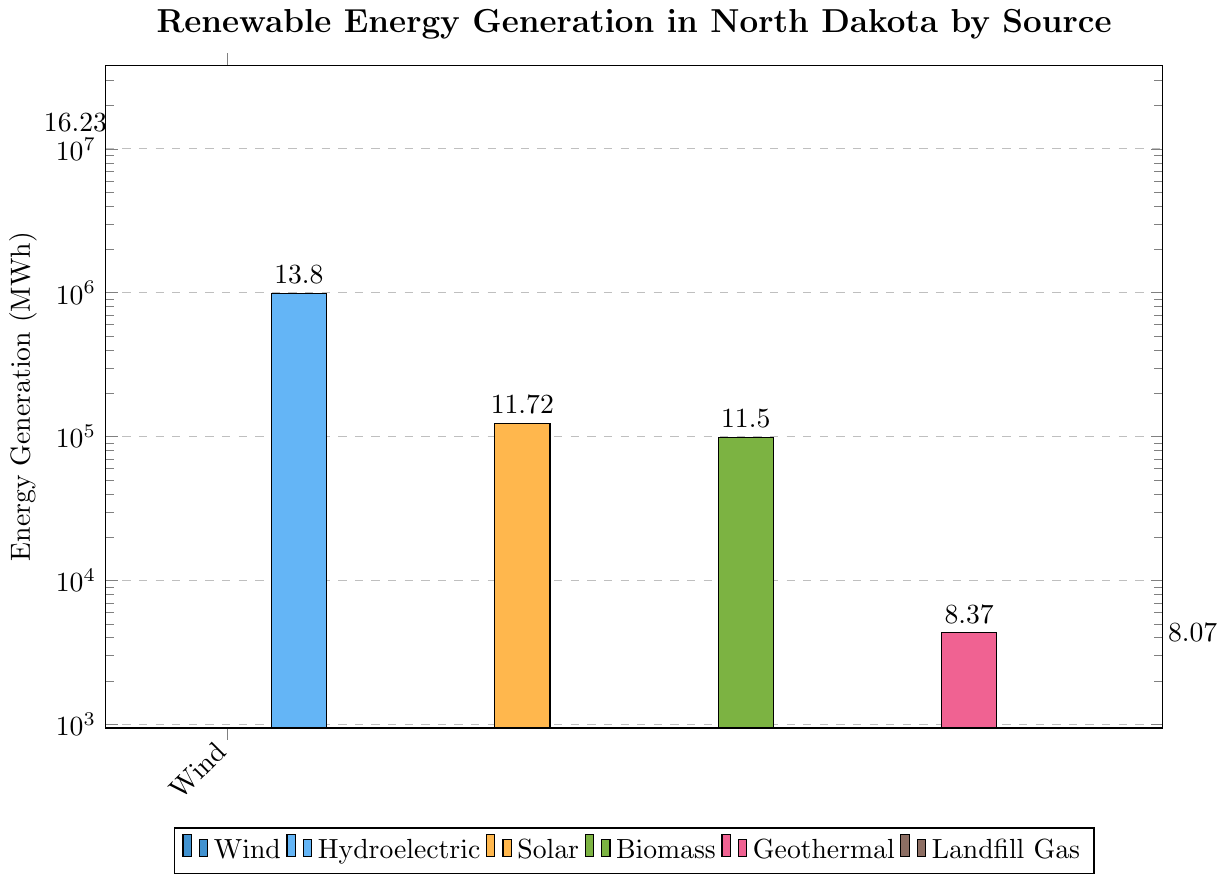Which source generates the most energy in North Dakota? The tallest bar in the chart represents the source that generates the most energy. The Wind energy bar is the tallest.
Answer: Wind Which renewable energy source generates the least amount of energy in North Dakota? The shortest bar in the chart represents the source that generates the least energy. The Landfill Gas energy bar is the shortest.
Answer: Landfill Gas How much more energy is generated by Wind compared to Hydroelectric? Subtract the energy generation of Hydroelectric from Wind. Wind: 11234567 MWh, Hydroelectric: 987654 MWh, the difference is 11234567 - 987654 = 10246913 MWh.
Answer: 10246913 MWh How does Biomass energy generation compare to Geothermal energy generation? Biomass generation value is 98765 MWh, and Geothermal generation value is 4321 MWh. Biomass > Geothermal.
Answer: Biomass generates more energy than Geothermal What's the total energy generation of Solar, Biomass, and Geothermal combined? Sum the energy generation of Solar, Biomass, and Geothermal. Solar: 123456 MWh, Biomass: 98765 MWh, Geothermal: 4321 MWh. The total is 123456 + 98765 + 4321 = 226542 MWh.
Answer: 226542 MWh Which sources have an energy generation amount greater than 1000000 MWh? Identify bars with heights representing values greater than 1000000 MWh. Wind (11234567 MWh) and Hydroelectric (987654 MWh) are considered, but only Wind exceeds 1000000 MWh.
Answer: Wind How many sources generate less than 200000 MWh of energy? Count the bars with heights representing values less than 200000 MWh. The sources are Solar (123456 MWh), Biomass (98765 MWh), Geothermal (4321 MWh), and Landfill Gas (3210 MWh).
Answer: 4 sources What is the difference in energy generation between Solar and Biomass? Subtract the energy generation of Biomass from Solar. Solar: 123456 MWh, Biomass: 98765 MWh, the difference is 123456 - 98765 = 24701 MWh.
Answer: 24701 MWh What is the median energy generation value among all sources? Arrange the energy generation values in ascending order: 3210, 4321, 98765, 123456, 987654, 11234567. The median is the average of the two middle values: (98765 + 123456) / 2 = 111610.5 MWh.
Answer: 111610.5 MWh Which bar is colored green? The bar representing Biomass energy has a green color.
Answer: Biomass 